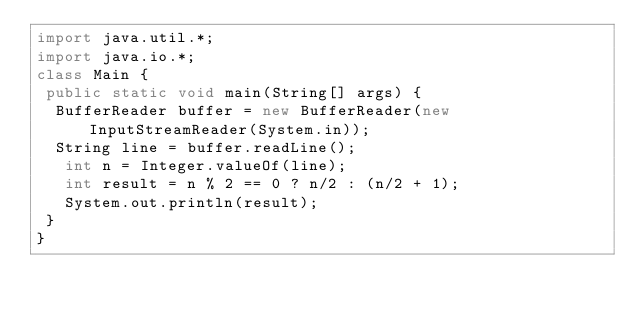Convert code to text. <code><loc_0><loc_0><loc_500><loc_500><_Java_>import java.util.*;
import java.io.*;
class Main {
 public static void main(String[] args) {
  BufferReader buffer = new BufferReader(new InputStreamReader(System.in));
  String line = buffer.readLine();
   int n = Integer.valueOf(line);
   int result = n % 2 == 0 ? n/2 : (n/2 + 1);
   System.out.println(result);
 }
}</code> 